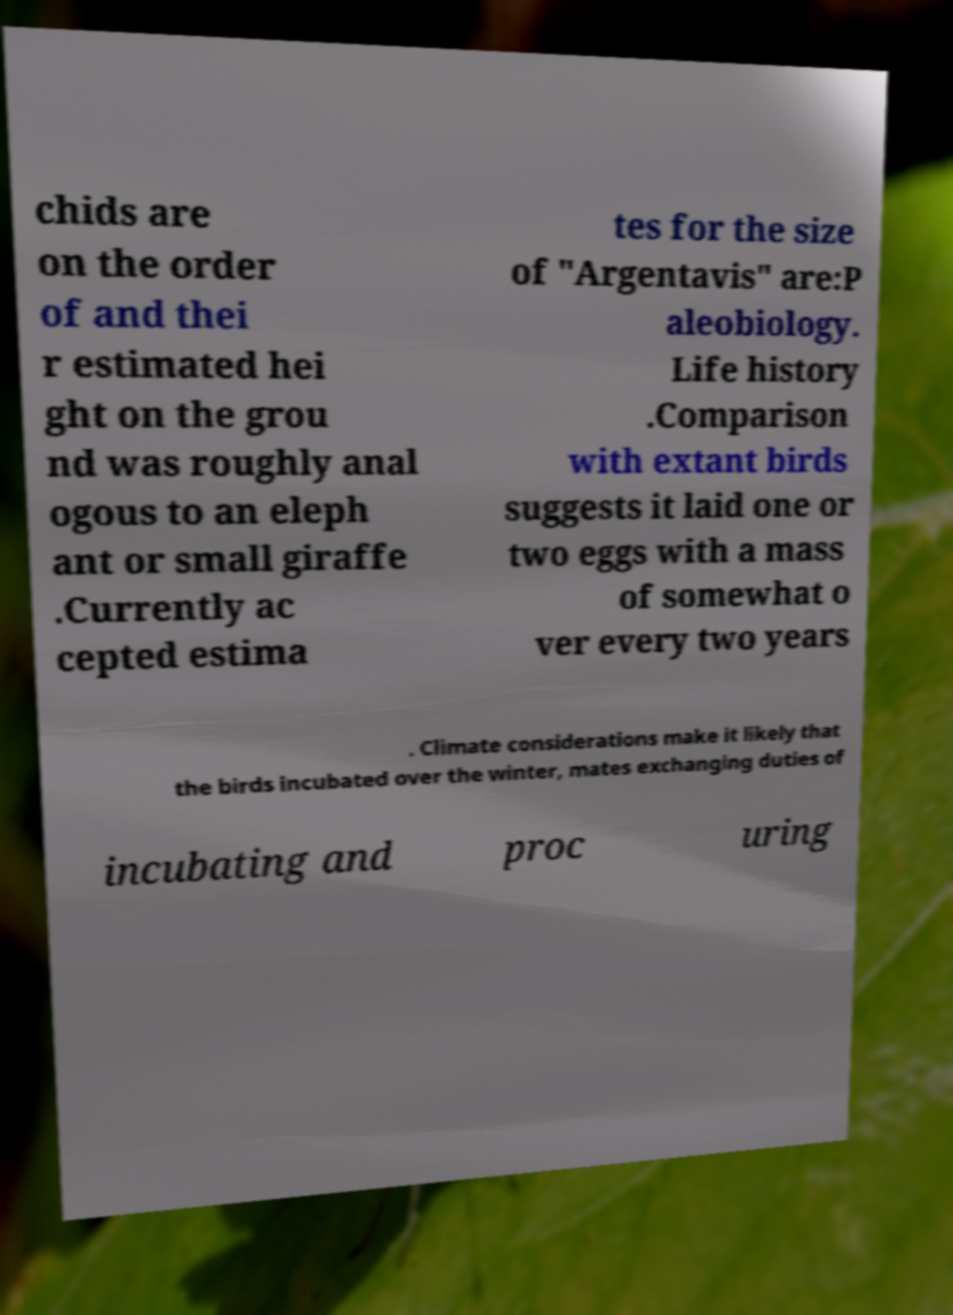There's text embedded in this image that I need extracted. Can you transcribe it verbatim? chids are on the order of and thei r estimated hei ght on the grou nd was roughly anal ogous to an eleph ant or small giraffe .Currently ac cepted estima tes for the size of "Argentavis" are:P aleobiology. Life history .Comparison with extant birds suggests it laid one or two eggs with a mass of somewhat o ver every two years . Climate considerations make it likely that the birds incubated over the winter, mates exchanging duties of incubating and proc uring 